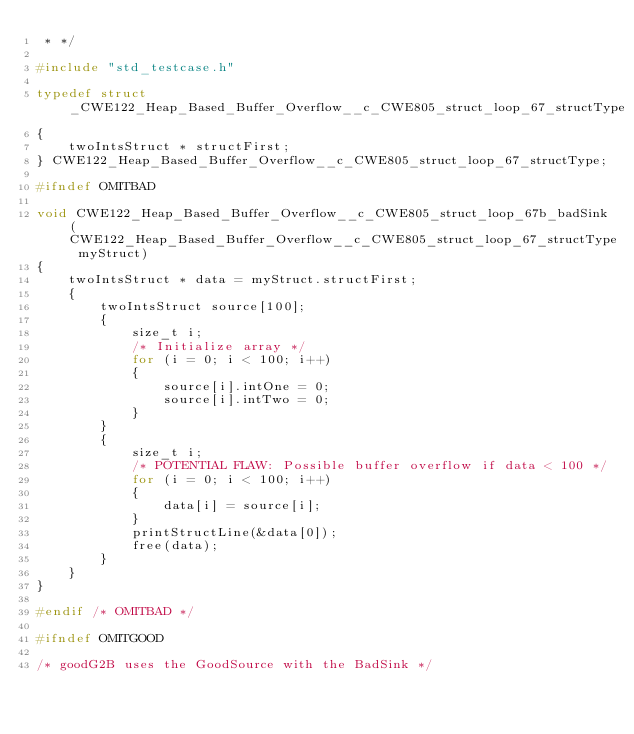<code> <loc_0><loc_0><loc_500><loc_500><_C_> * */

#include "std_testcase.h"

typedef struct _CWE122_Heap_Based_Buffer_Overflow__c_CWE805_struct_loop_67_structType
{
    twoIntsStruct * structFirst;
} CWE122_Heap_Based_Buffer_Overflow__c_CWE805_struct_loop_67_structType;

#ifndef OMITBAD

void CWE122_Heap_Based_Buffer_Overflow__c_CWE805_struct_loop_67b_badSink(CWE122_Heap_Based_Buffer_Overflow__c_CWE805_struct_loop_67_structType myStruct)
{
    twoIntsStruct * data = myStruct.structFirst;
    {
        twoIntsStruct source[100];
        {
            size_t i;
            /* Initialize array */
            for (i = 0; i < 100; i++)
            {
                source[i].intOne = 0;
                source[i].intTwo = 0;
            }
        }
        {
            size_t i;
            /* POTENTIAL FLAW: Possible buffer overflow if data < 100 */
            for (i = 0; i < 100; i++)
            {
                data[i] = source[i];
            }
            printStructLine(&data[0]);
            free(data);
        }
    }
}

#endif /* OMITBAD */

#ifndef OMITGOOD

/* goodG2B uses the GoodSource with the BadSink */</code> 